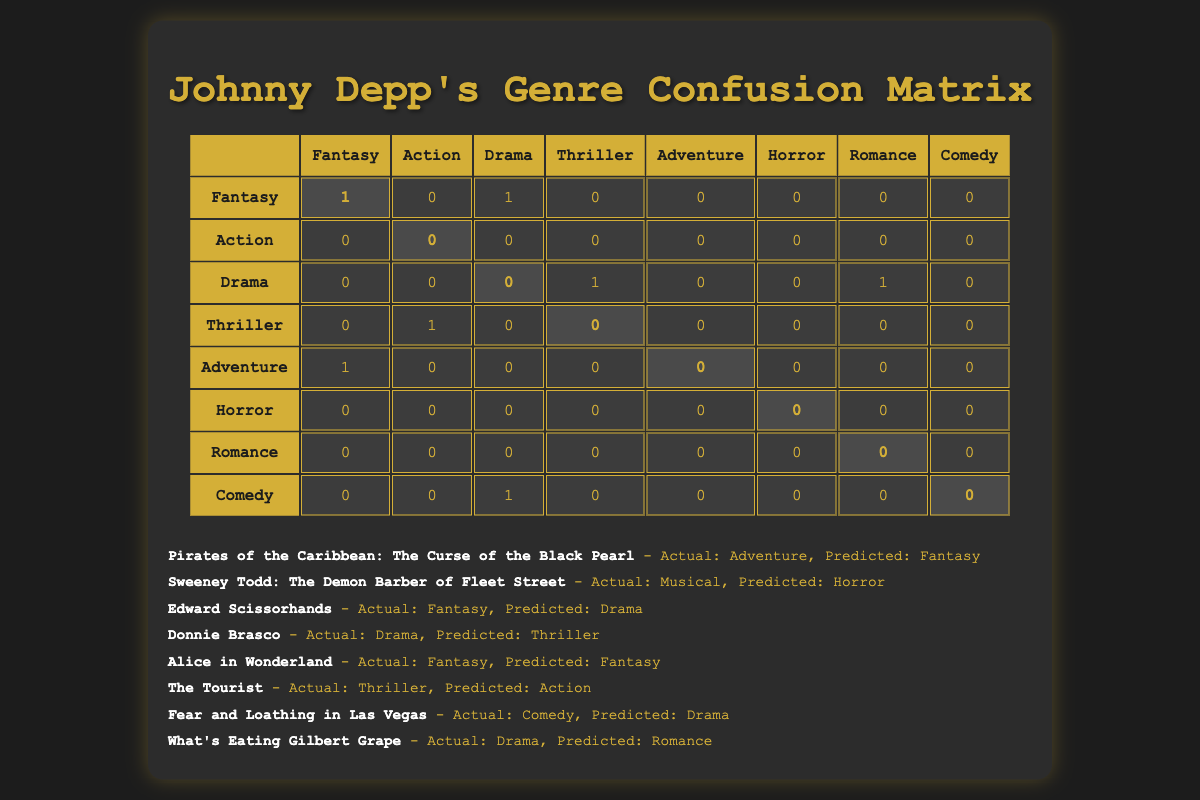What's the number of films predicted as Fantasy? From the confusion matrix, only one entry in the "Fantasy" row has a value greater than zero. That is found in the diagonal position where the actual and predicted genres match. Therefore, the number of films predicted as Fantasy is 1.
Answer: 1 How many Johnny Depp films were correctly classified into their actual genres? The diagonal values in the confusion matrix represent correct classifications. From the diagonal, the counts indicate that one film was correctly classified as Fantasy (Alice in Wonderland), and zero for all other genres. Therefore, the total correct classifications sum up to 1.
Answer: 1 Which genre had the highest count of misclassifications? To find the genre with the highest misclassification, I will sum the off-diagonal counts for each genre. By examining the matrix, "Action" has the highest count of misclassifications: there is one misclassification where "Thriller" was incorrectly predicted as "Action." Hence, the highest count of misclassifications is for "Action."
Answer: Action Are there any films that were predicted as Comedy? Checking the "Comedy" row, there are no entries where the actual genre is Comedy with a corresponding prediction. Thus, none of the films in the list were predicted as Comedy.
Answer: No How many total films were evaluated in this prediction? There are eight films listed, each corresponding to a unique entry in the confusion matrix. Therefore, the total number of films evaluated is simply the count of these entries.
Answer: 8 What genre had the highest number of actual films but was entirely misclassified? From the confusion matrix, "Action" shows no diagonal entry, indicating that all "Action" films were misclassified. Hence, "Action" had the highest number of actual films (which was 1) that were entirely misclassified.
Answer: Action For the genres where predictions were made, what percentage were correctly predicted? There were 2 correct predictions out of a total of 8 films evaluated. The percentage of correctly predicted genres is calculated as (2/8) * 100 = 25%.
Answer: 25% Is it true that all predicted films for the Horror genre were correctly classified? Reviewing the confusion matrix, the Horror row shows a diagonal entry of 0, indicating that it was never predicted correctly. Therefore, it is false that all predicted films for the Horror genre were correctly classified.
Answer: No 